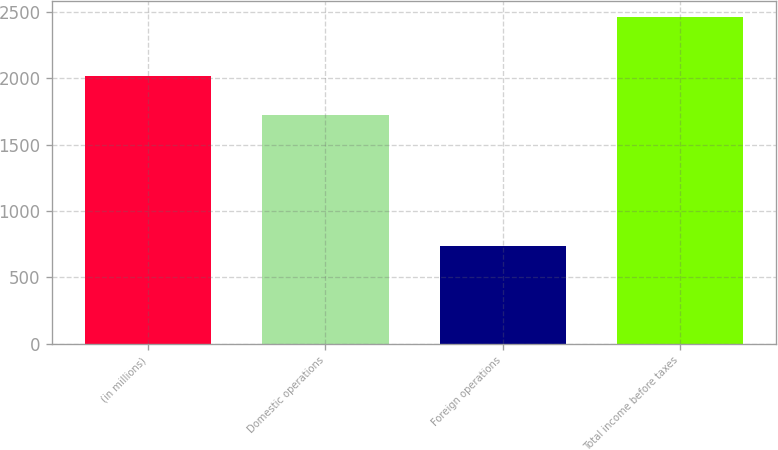Convert chart to OTSL. <chart><loc_0><loc_0><loc_500><loc_500><bar_chart><fcel>(in millions)<fcel>Domestic operations<fcel>Foreign operations<fcel>Total income before taxes<nl><fcel>2017<fcel>1723<fcel>738<fcel>2461<nl></chart> 